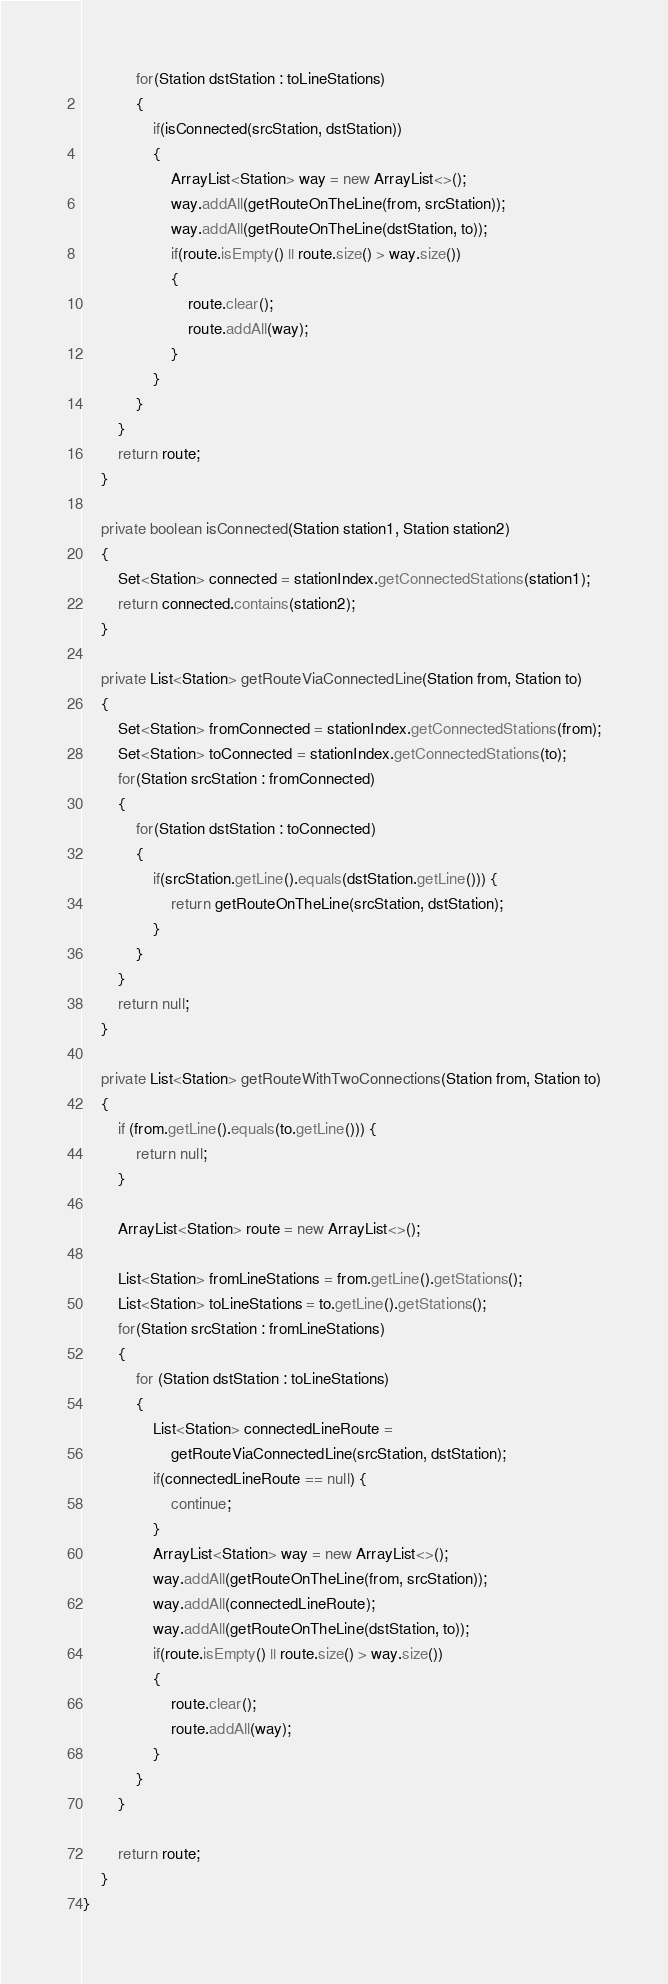Convert code to text. <code><loc_0><loc_0><loc_500><loc_500><_Java_>            for(Station dstStation : toLineStations)
            {
                if(isConnected(srcStation, dstStation))
                {
                    ArrayList<Station> way = new ArrayList<>();
                    way.addAll(getRouteOnTheLine(from, srcStation));
                    way.addAll(getRouteOnTheLine(dstStation, to));
                    if(route.isEmpty() || route.size() > way.size())
                    {
                        route.clear();
                        route.addAll(way);
                    }
                }
            }
        }
        return route;
    }

    private boolean isConnected(Station station1, Station station2)
    {
        Set<Station> connected = stationIndex.getConnectedStations(station1);
        return connected.contains(station2);
    }

    private List<Station> getRouteViaConnectedLine(Station from, Station to)
    {
        Set<Station> fromConnected = stationIndex.getConnectedStations(from);
        Set<Station> toConnected = stationIndex.getConnectedStations(to);
        for(Station srcStation : fromConnected)
        {
            for(Station dstStation : toConnected)
            {
                if(srcStation.getLine().equals(dstStation.getLine())) {
                    return getRouteOnTheLine(srcStation, dstStation);
                }
            }
        }
        return null;
    }

    private List<Station> getRouteWithTwoConnections(Station from, Station to)
    {
        if (from.getLine().equals(to.getLine())) {
            return null;
        }

        ArrayList<Station> route = new ArrayList<>();

        List<Station> fromLineStations = from.getLine().getStations();
        List<Station> toLineStations = to.getLine().getStations();
        for(Station srcStation : fromLineStations)
        {
            for (Station dstStation : toLineStations)
            {
                List<Station> connectedLineRoute =
                    getRouteViaConnectedLine(srcStation, dstStation);
                if(connectedLineRoute == null) {
                    continue;
                }
                ArrayList<Station> way = new ArrayList<>();
                way.addAll(getRouteOnTheLine(from, srcStation));
                way.addAll(connectedLineRoute);
                way.addAll(getRouteOnTheLine(dstStation, to));
                if(route.isEmpty() || route.size() > way.size())
                {
                    route.clear();
                    route.addAll(way);
                }
            }
        }

        return route;
    }
}</code> 